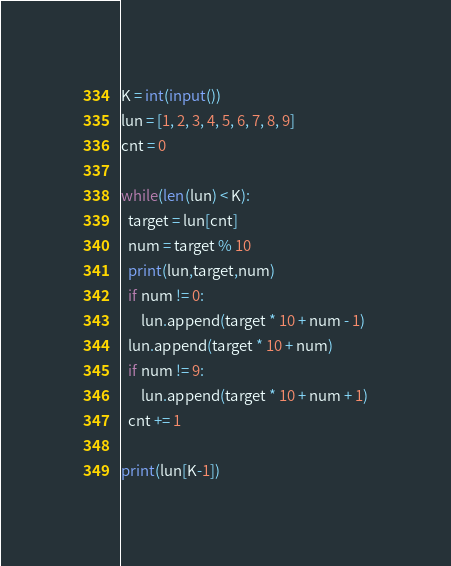<code> <loc_0><loc_0><loc_500><loc_500><_Python_>K = int(input())
lun = [1, 2, 3, 4, 5, 6, 7, 8, 9]
cnt = 0

while(len(lun) < K):
  target = lun[cnt]
  num = target % 10
  print(lun,target,num)
  if num != 0:
      lun.append(target * 10 + num - 1)
  lun.append(target * 10 + num)
  if num != 9:
      lun.append(target * 10 + num + 1)
  cnt += 1

print(lun[K-1])
</code> 